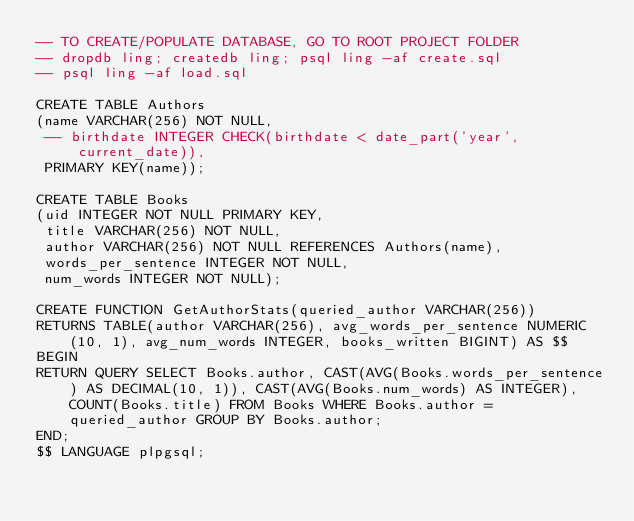Convert code to text. <code><loc_0><loc_0><loc_500><loc_500><_SQL_>-- TO CREATE/POPULATE DATABASE, GO TO ROOT PROJECT FOLDER
-- dropdb ling; createdb ling; psql ling -af create.sql
-- psql ling -af load.sql

CREATE TABLE Authors
(name VARCHAR(256) NOT NULL,
 -- birthdate INTEGER CHECK(birthdate < date_part('year', current_date)),
 PRIMARY KEY(name));

CREATE TABLE Books
(uid INTEGER NOT NULL PRIMARY KEY,
 title VARCHAR(256) NOT NULL,
 author VARCHAR(256) NOT NULL REFERENCES Authors(name),
 words_per_sentence INTEGER NOT NULL,
 num_words INTEGER NOT NULL);

CREATE FUNCTION GetAuthorStats(queried_author VARCHAR(256))
RETURNS TABLE(author VARCHAR(256), avg_words_per_sentence NUMERIC(10, 1), avg_num_words INTEGER, books_written BIGINT) AS $$
BEGIN
RETURN QUERY SELECT Books.author, CAST(AVG(Books.words_per_sentence) AS DECIMAL(10, 1)), CAST(AVG(Books.num_words) AS INTEGER), COUNT(Books.title) FROM Books WHERE Books.author = queried_author GROUP BY Books.author;
END;
$$ LANGUAGE plpgsql;</code> 